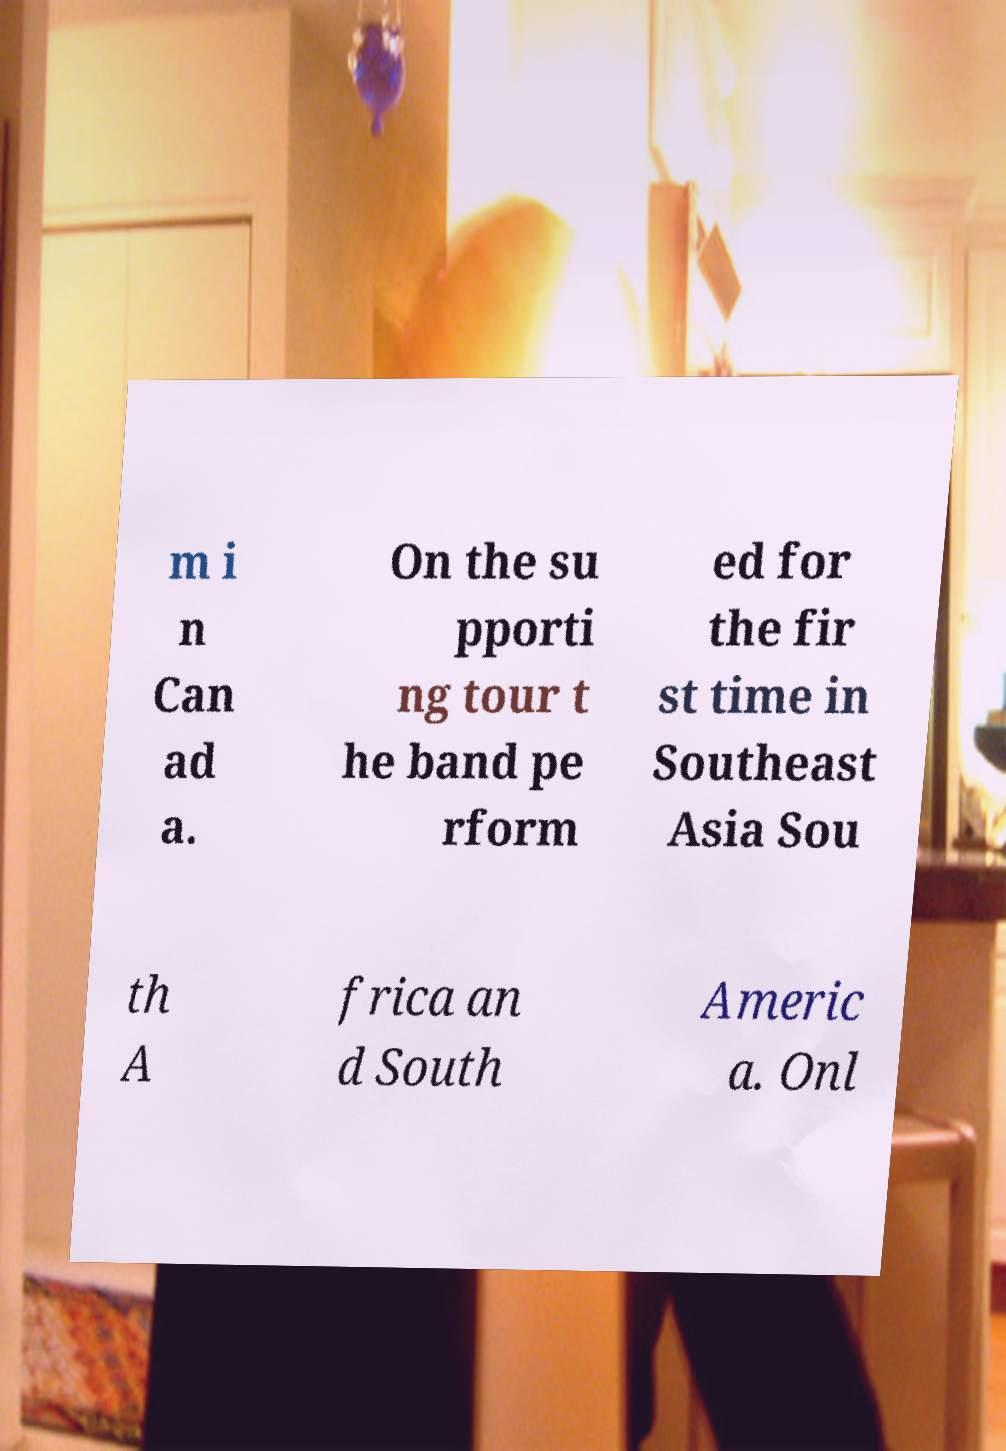What messages or text are displayed in this image? I need them in a readable, typed format. m i n Can ad a. On the su pporti ng tour t he band pe rform ed for the fir st time in Southeast Asia Sou th A frica an d South Americ a. Onl 